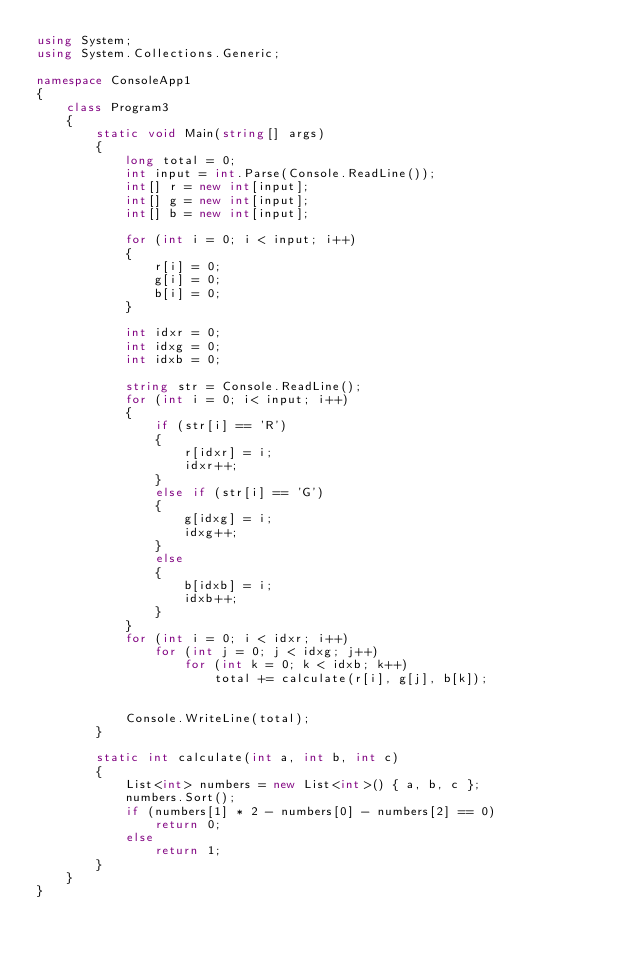Convert code to text. <code><loc_0><loc_0><loc_500><loc_500><_C#_>using System;
using System.Collections.Generic;

namespace ConsoleApp1
{
    class Program3
    {
        static void Main(string[] args)
        {
            long total = 0;
            int input = int.Parse(Console.ReadLine());
            int[] r = new int[input];
            int[] g = new int[input];
            int[] b = new int[input];

            for (int i = 0; i < input; i++)
            {
                r[i] = 0;
                g[i] = 0;
                b[i] = 0;
            }

            int idxr = 0;
            int idxg = 0;
            int idxb = 0;

            string str = Console.ReadLine();
            for (int i = 0; i< input; i++)
            {
                if (str[i] == 'R')
                {
                    r[idxr] = i;
                    idxr++;
                }
                else if (str[i] == 'G')
                {
                    g[idxg] = i;
                    idxg++;
                }
                else
                {
                    b[idxb] = i;
                    idxb++;
                }
            }
            for (int i = 0; i < idxr; i++)
                for (int j = 0; j < idxg; j++)
                    for (int k = 0; k < idxb; k++)
                        total += calculate(r[i], g[j], b[k]);


            Console.WriteLine(total);
        }

        static int calculate(int a, int b, int c)
        {
            List<int> numbers = new List<int>() { a, b, c };
            numbers.Sort();
            if (numbers[1] * 2 - numbers[0] - numbers[2] == 0)
                return 0;
            else
                return 1;
        }
    }
}
</code> 